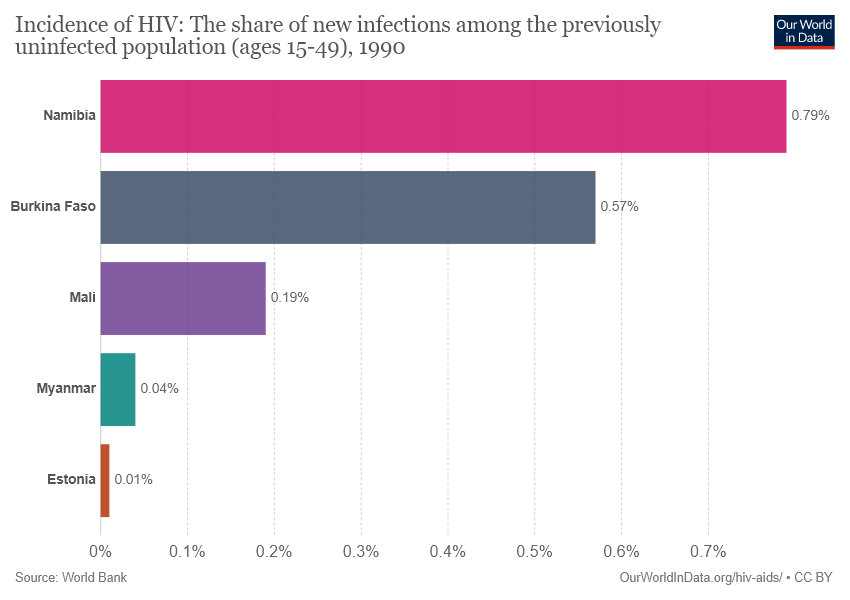Identify some key points in this picture. The sum of the last four bars is greater than Namibia. There are five color bars displayed in the chart. 